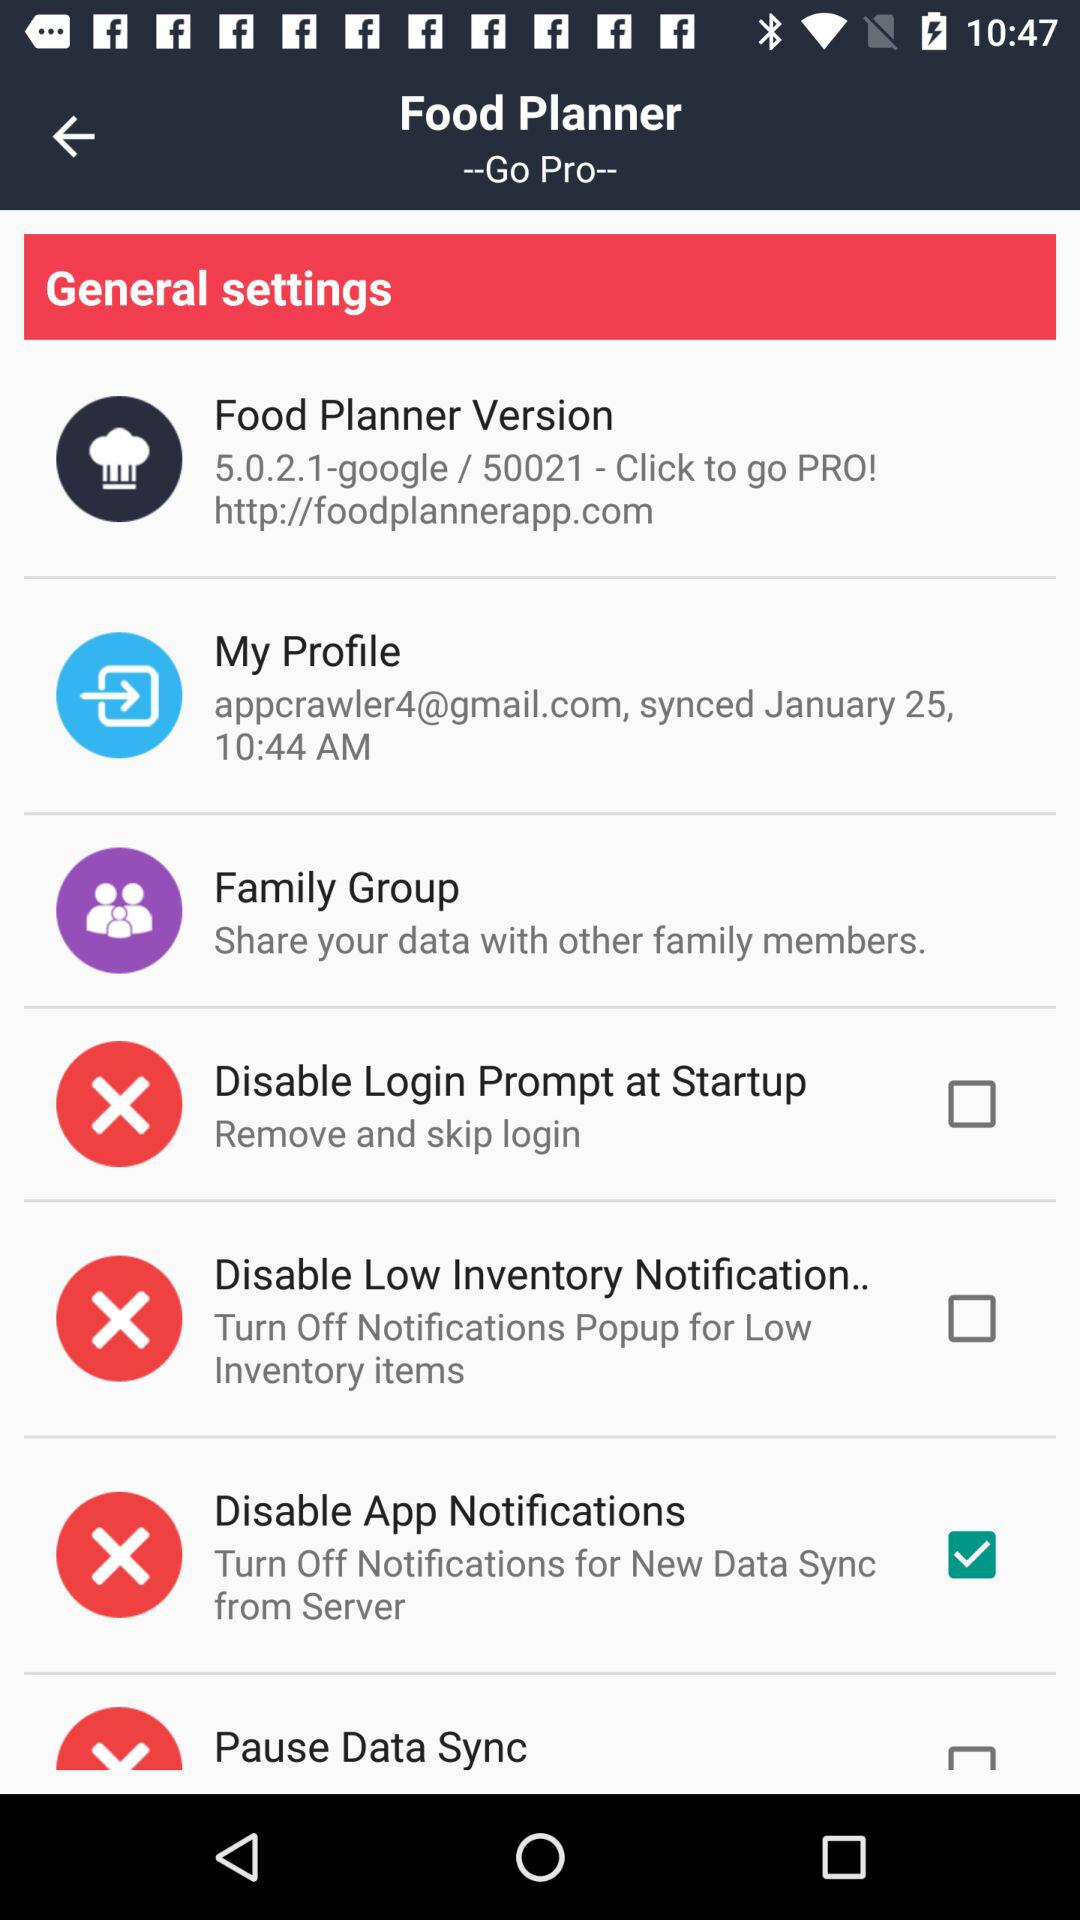What is the name of the application? The name of the application is "Food Planner". 